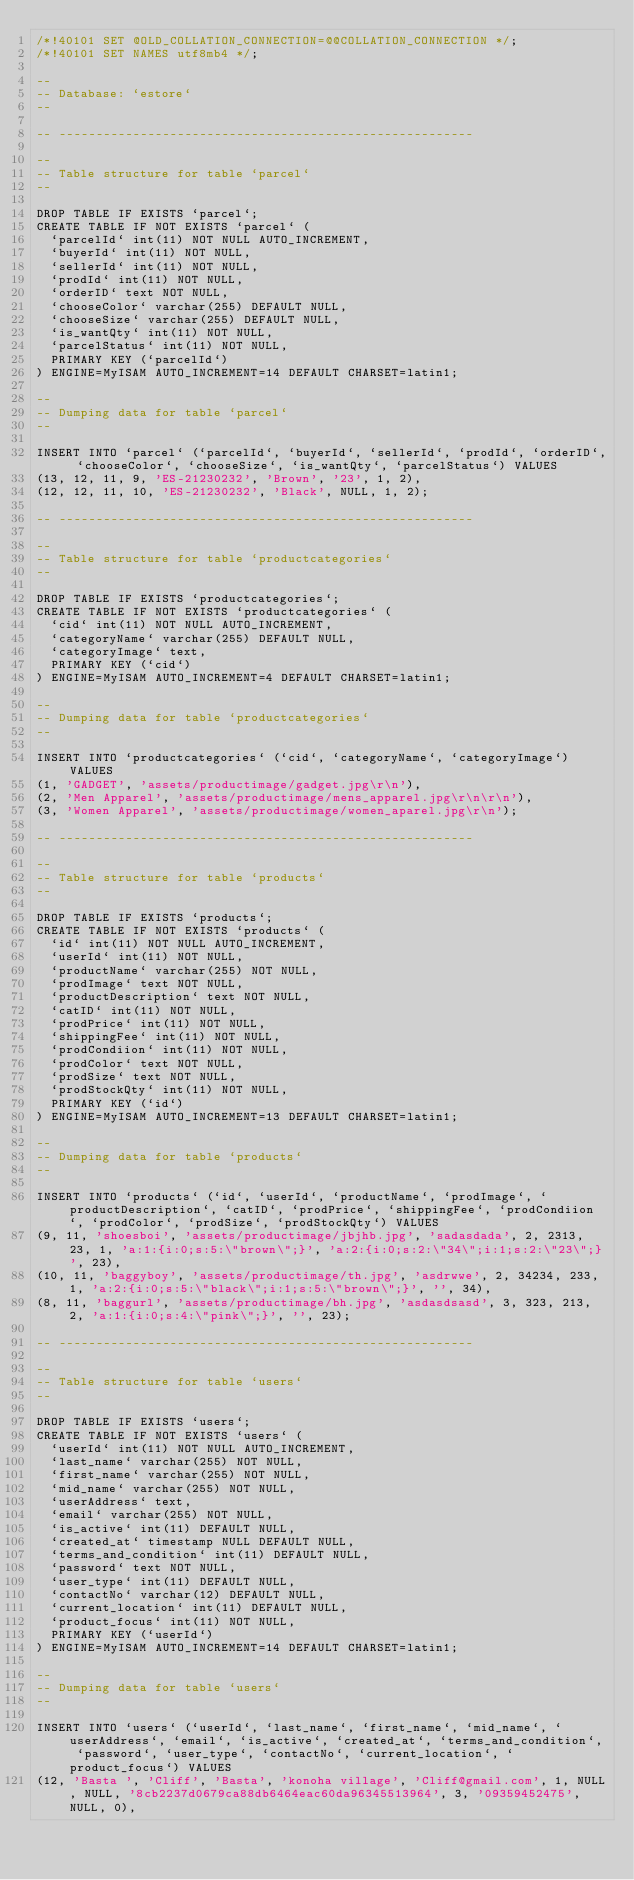<code> <loc_0><loc_0><loc_500><loc_500><_SQL_>/*!40101 SET @OLD_COLLATION_CONNECTION=@@COLLATION_CONNECTION */;
/*!40101 SET NAMES utf8mb4 */;

--
-- Database: `estore`
--

-- --------------------------------------------------------

--
-- Table structure for table `parcel`
--

DROP TABLE IF EXISTS `parcel`;
CREATE TABLE IF NOT EXISTS `parcel` (
  `parcelId` int(11) NOT NULL AUTO_INCREMENT,
  `buyerId` int(11) NOT NULL,
  `sellerId` int(11) NOT NULL,
  `prodId` int(11) NOT NULL,
  `orderID` text NOT NULL,
  `chooseColor` varchar(255) DEFAULT NULL,
  `chooseSize` varchar(255) DEFAULT NULL,
  `is_wantQty` int(11) NOT NULL,
  `parcelStatus` int(11) NOT NULL,
  PRIMARY KEY (`parcelId`)
) ENGINE=MyISAM AUTO_INCREMENT=14 DEFAULT CHARSET=latin1;

--
-- Dumping data for table `parcel`
--

INSERT INTO `parcel` (`parcelId`, `buyerId`, `sellerId`, `prodId`, `orderID`, `chooseColor`, `chooseSize`, `is_wantQty`, `parcelStatus`) VALUES
(13, 12, 11, 9, 'ES-21230232', 'Brown', '23', 1, 2),
(12, 12, 11, 10, 'ES-21230232', 'Black', NULL, 1, 2);

-- --------------------------------------------------------

--
-- Table structure for table `productcategories`
--

DROP TABLE IF EXISTS `productcategories`;
CREATE TABLE IF NOT EXISTS `productcategories` (
  `cid` int(11) NOT NULL AUTO_INCREMENT,
  `categoryName` varchar(255) DEFAULT NULL,
  `categoryImage` text,
  PRIMARY KEY (`cid`)
) ENGINE=MyISAM AUTO_INCREMENT=4 DEFAULT CHARSET=latin1;

--
-- Dumping data for table `productcategories`
--

INSERT INTO `productcategories` (`cid`, `categoryName`, `categoryImage`) VALUES
(1, 'GADGET', 'assets/productimage/gadget.jpg\r\n'),
(2, 'Men Apparel', 'assets/productimage/mens_apparel.jpg\r\n\r\n'),
(3, 'Women Apparel', 'assets/productimage/women_aparel.jpg\r\n');

-- --------------------------------------------------------

--
-- Table structure for table `products`
--

DROP TABLE IF EXISTS `products`;
CREATE TABLE IF NOT EXISTS `products` (
  `id` int(11) NOT NULL AUTO_INCREMENT,
  `userId` int(11) NOT NULL,
  `productName` varchar(255) NOT NULL,
  `prodImage` text NOT NULL,
  `productDescription` text NOT NULL,
  `catID` int(11) NOT NULL,
  `prodPrice` int(11) NOT NULL,
  `shippingFee` int(11) NOT NULL,
  `prodCondiion` int(11) NOT NULL,
  `prodColor` text NOT NULL,
  `prodSize` text NOT NULL,
  `prodStockQty` int(11) NOT NULL,
  PRIMARY KEY (`id`)
) ENGINE=MyISAM AUTO_INCREMENT=13 DEFAULT CHARSET=latin1;

--
-- Dumping data for table `products`
--

INSERT INTO `products` (`id`, `userId`, `productName`, `prodImage`, `productDescription`, `catID`, `prodPrice`, `shippingFee`, `prodCondiion`, `prodColor`, `prodSize`, `prodStockQty`) VALUES
(9, 11, 'shoesboi', 'assets/productimage/jbjhb.jpg', 'sadasdada', 2, 2313, 23, 1, 'a:1:{i:0;s:5:\"brown\";}', 'a:2:{i:0;s:2:\"34\";i:1;s:2:\"23\";}', 23),
(10, 11, 'baggyboy', 'assets/productimage/th.jpg', 'asdrwwe', 2, 34234, 233, 1, 'a:2:{i:0;s:5:\"black\";i:1;s:5:\"brown\";}', '', 34),
(8, 11, 'baggurl', 'assets/productimage/bh.jpg', 'asdasdsasd', 3, 323, 213, 2, 'a:1:{i:0;s:4:\"pink\";}', '', 23);

-- --------------------------------------------------------

--
-- Table structure for table `users`
--

DROP TABLE IF EXISTS `users`;
CREATE TABLE IF NOT EXISTS `users` (
  `userId` int(11) NOT NULL AUTO_INCREMENT,
  `last_name` varchar(255) NOT NULL,
  `first_name` varchar(255) NOT NULL,
  `mid_name` varchar(255) NOT NULL,
  `userAddress` text,
  `email` varchar(255) NOT NULL,
  `is_active` int(11) DEFAULT NULL,
  `created_at` timestamp NULL DEFAULT NULL,
  `terms_and_condition` int(11) DEFAULT NULL,
  `password` text NOT NULL,
  `user_type` int(11) DEFAULT NULL,
  `contactNo` varchar(12) DEFAULT NULL,
  `current_location` int(11) DEFAULT NULL,
  `product_focus` int(11) NOT NULL,
  PRIMARY KEY (`userId`)
) ENGINE=MyISAM AUTO_INCREMENT=14 DEFAULT CHARSET=latin1;

--
-- Dumping data for table `users`
--

INSERT INTO `users` (`userId`, `last_name`, `first_name`, `mid_name`, `userAddress`, `email`, `is_active`, `created_at`, `terms_and_condition`, `password`, `user_type`, `contactNo`, `current_location`, `product_focus`) VALUES
(12, 'Basta ', 'Cliff', 'Basta', 'konoha village', 'Cliff@gmail.com', 1, NULL, NULL, '8cb2237d0679ca88db6464eac60da96345513964', 3, '09359452475', NULL, 0),</code> 